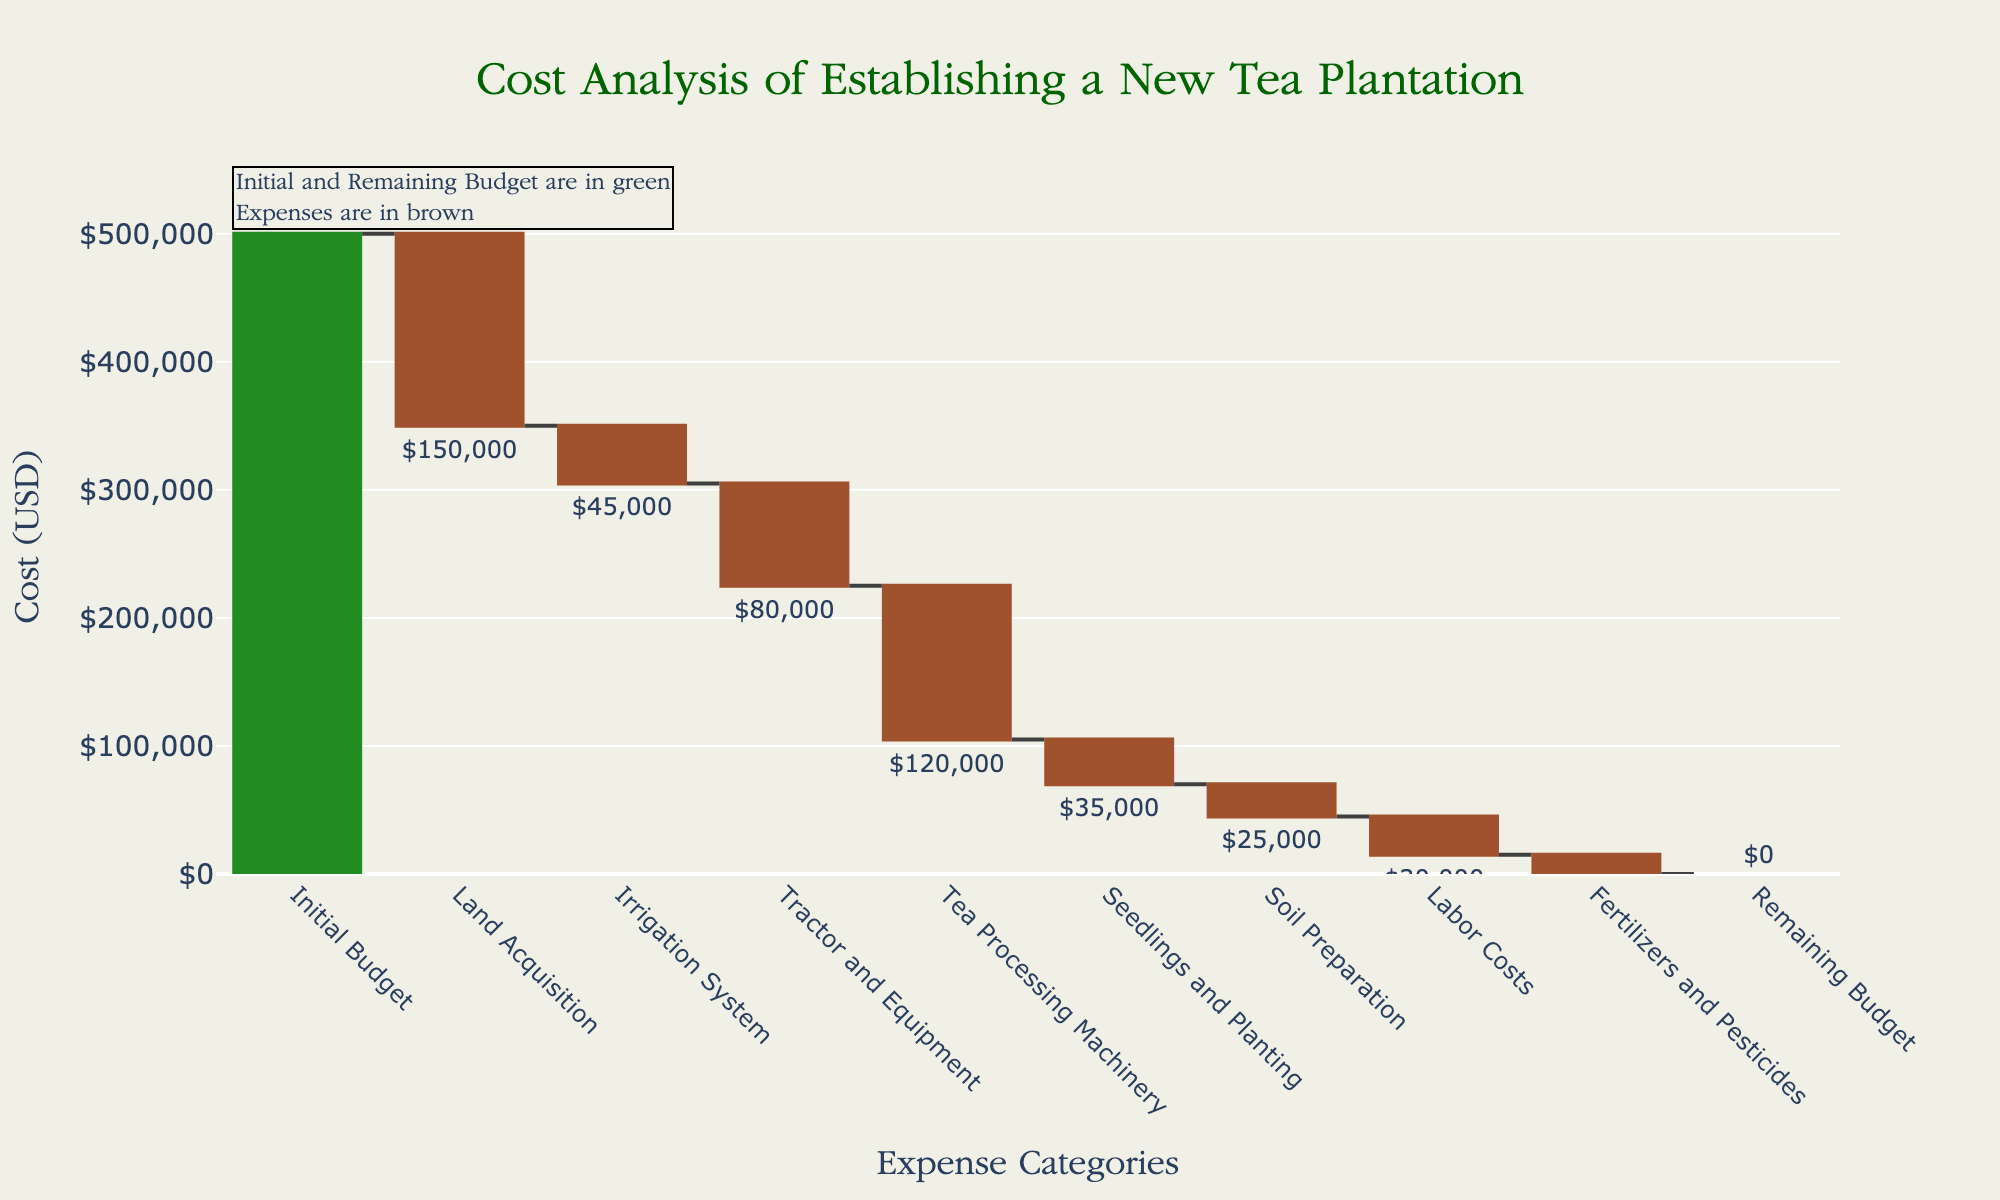What is the initial budget for establishing the new tea plantation? The initial budget is the first value shown in the waterfall chart and is labeled "Initial Budget" with a visual marker indicating the amount.
Answer: \$500,000 How much was spent on land acquisition? The amount spent on land acquisition can be found by looking at the category labeled "Land Acquisition" and noting the value associated with it.
Answer: \$150,000 What is the total cost of irrigation system and tea processing machinery combined? To find the total cost, sum the values associated with the categories "Irrigation System" and "Tea Processing Machinery". This is \$45,000 + \$120,000.
Answer: \$165,000 Which expense category had the lowest cost? To identify the category with the lowest cost, compare all the expense values and find the minimum one, which is associated with "Fertilizers and Pesticides".
Answer: \$15,000 How much is the remaining budget after accounting for all expenses? The remaining budget is the last value shown in the waterfall chart, labeled as "Remaining Budget".
Answer: \$0 By how much did the labor costs exceed the costs for soil preparation? Subtract the cost of "Soil Preparation" from the cost of "Labor Costs". This is \$30,000 - \$25,000.
Answer: \$5,000 What is the difference between the initial budget and the total spent on equipment (tractor, machinery)? Add the costs of "Tractor and Equipment" and "Tea Processing Machinery", and subtract this sum from the initial budget. This is \$500,000 - (\$80,000 + \$120,000).
Answer: \$300,000 Which expense category decreased the budget the most? Identify the category with the highest negative value, which is "Tea Processing Machinery".
Answer: \$120,000 What are the two highest expense categories? Identify the two categories with the highest negative values. These are "Tea Processing Machinery" and "Land Acquisition".
Answer: Tea Processing Machinery and Land Acquisition How much of the initial budget was spent on cultivation-related activities (soil preparation, seedlings and planting, fertilizers and pesticides)? Sum the costs of "Soil Preparation", "Seedlings and Planting", and "Fertilizers and Pesticides". This is \$25,000 + \$35,000 + \$15,000.
Answer: \$75,000 